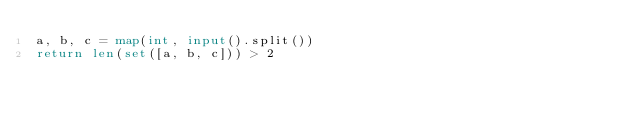<code> <loc_0><loc_0><loc_500><loc_500><_Python_>a, b, c = map(int, input().split())
return len(set([a, b, c])) > 2</code> 